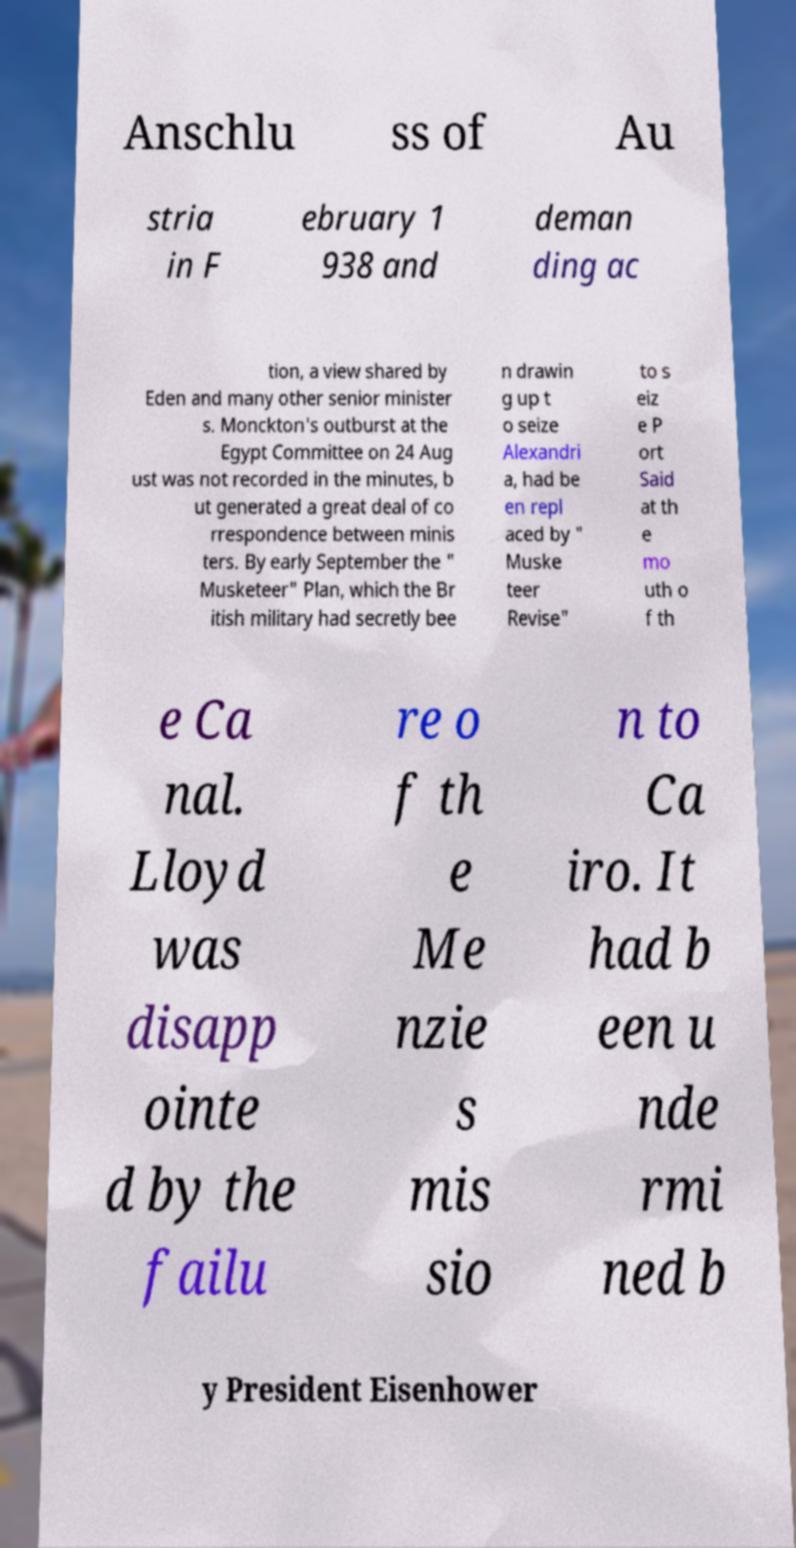Please read and relay the text visible in this image. What does it say? Anschlu ss of Au stria in F ebruary 1 938 and deman ding ac tion, a view shared by Eden and many other senior minister s. Monckton's outburst at the Egypt Committee on 24 Aug ust was not recorded in the minutes, b ut generated a great deal of co rrespondence between minis ters. By early September the " Musketeer" Plan, which the Br itish military had secretly bee n drawin g up t o seize Alexandri a, had be en repl aced by " Muske teer Revise" to s eiz e P ort Said at th e mo uth o f th e Ca nal. Lloyd was disapp ointe d by the failu re o f th e Me nzie s mis sio n to Ca iro. It had b een u nde rmi ned b y President Eisenhower 